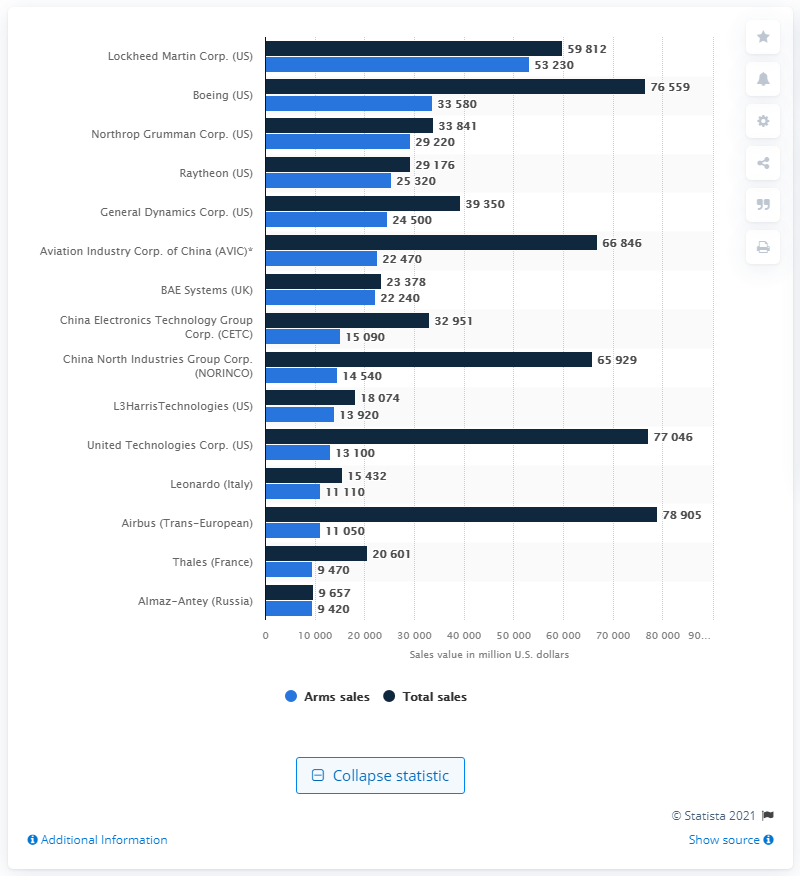Outline some significant characteristics in this image. According to the information available, Lockheed Martin's arms sales in 2019 totaled approximately 53,230. 